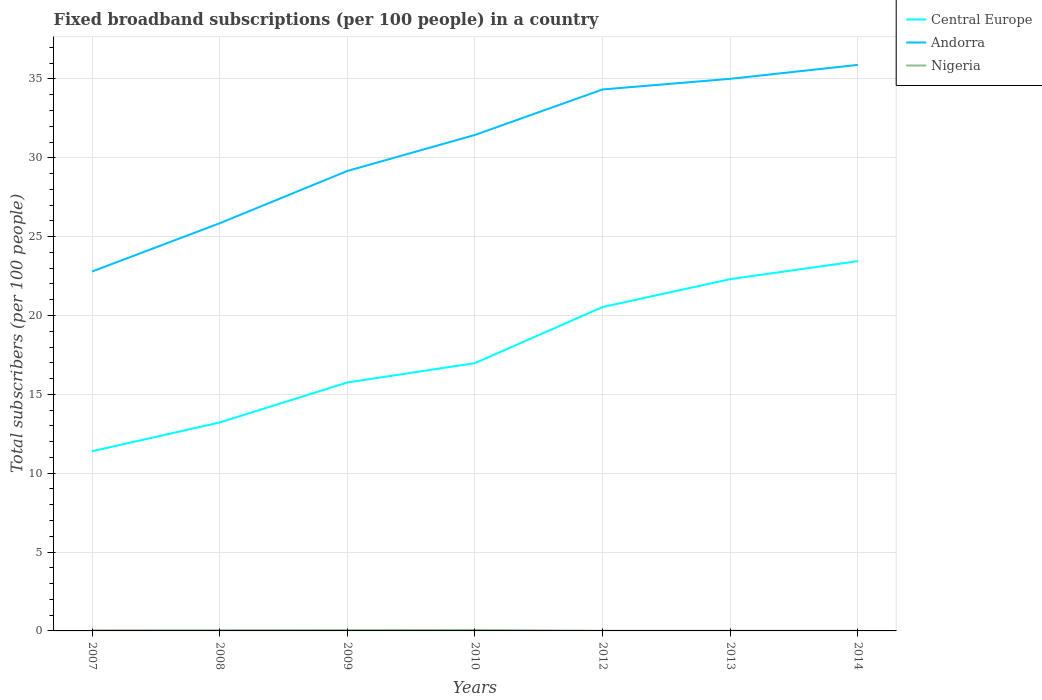How many different coloured lines are there?
Your answer should be compact. 3. Is the number of lines equal to the number of legend labels?
Give a very brief answer. Yes. Across all years, what is the maximum number of broadband subscriptions in Nigeria?
Provide a short and direct response. 0.01. What is the total number of broadband subscriptions in Nigeria in the graph?
Your response must be concise. 0.05. What is the difference between the highest and the second highest number of broadband subscriptions in Andorra?
Provide a short and direct response. 13.1. How many lines are there?
Provide a succinct answer. 3. How many years are there in the graph?
Give a very brief answer. 7. What is the difference between two consecutive major ticks on the Y-axis?
Provide a short and direct response. 5. Are the values on the major ticks of Y-axis written in scientific E-notation?
Offer a very short reply. No. Does the graph contain any zero values?
Offer a very short reply. No. How many legend labels are there?
Your response must be concise. 3. How are the legend labels stacked?
Make the answer very short. Vertical. What is the title of the graph?
Offer a terse response. Fixed broadband subscriptions (per 100 people) in a country. Does "Luxembourg" appear as one of the legend labels in the graph?
Offer a very short reply. No. What is the label or title of the X-axis?
Give a very brief answer. Years. What is the label or title of the Y-axis?
Your response must be concise. Total subscribers (per 100 people). What is the Total subscribers (per 100 people) in Central Europe in 2007?
Your answer should be very brief. 11.39. What is the Total subscribers (per 100 people) in Andorra in 2007?
Offer a very short reply. 22.79. What is the Total subscribers (per 100 people) in Nigeria in 2007?
Offer a very short reply. 0.04. What is the Total subscribers (per 100 people) of Central Europe in 2008?
Offer a terse response. 13.22. What is the Total subscribers (per 100 people) in Andorra in 2008?
Provide a succinct answer. 25.85. What is the Total subscribers (per 100 people) of Nigeria in 2008?
Give a very brief answer. 0.04. What is the Total subscribers (per 100 people) of Central Europe in 2009?
Offer a terse response. 15.75. What is the Total subscribers (per 100 people) in Andorra in 2009?
Make the answer very short. 29.17. What is the Total subscribers (per 100 people) in Nigeria in 2009?
Make the answer very short. 0.05. What is the Total subscribers (per 100 people) of Central Europe in 2010?
Offer a terse response. 16.98. What is the Total subscribers (per 100 people) in Andorra in 2010?
Your answer should be compact. 31.45. What is the Total subscribers (per 100 people) of Nigeria in 2010?
Make the answer very short. 0.06. What is the Total subscribers (per 100 people) of Central Europe in 2012?
Your response must be concise. 20.54. What is the Total subscribers (per 100 people) of Andorra in 2012?
Offer a terse response. 34.34. What is the Total subscribers (per 100 people) of Nigeria in 2012?
Give a very brief answer. 0.01. What is the Total subscribers (per 100 people) in Central Europe in 2013?
Your answer should be very brief. 22.31. What is the Total subscribers (per 100 people) of Andorra in 2013?
Make the answer very short. 35.01. What is the Total subscribers (per 100 people) in Nigeria in 2013?
Your answer should be compact. 0.01. What is the Total subscribers (per 100 people) in Central Europe in 2014?
Give a very brief answer. 23.45. What is the Total subscribers (per 100 people) in Andorra in 2014?
Offer a very short reply. 35.89. What is the Total subscribers (per 100 people) in Nigeria in 2014?
Provide a short and direct response. 0.01. Across all years, what is the maximum Total subscribers (per 100 people) of Central Europe?
Make the answer very short. 23.45. Across all years, what is the maximum Total subscribers (per 100 people) of Andorra?
Ensure brevity in your answer.  35.89. Across all years, what is the maximum Total subscribers (per 100 people) in Nigeria?
Offer a terse response. 0.06. Across all years, what is the minimum Total subscribers (per 100 people) in Central Europe?
Give a very brief answer. 11.39. Across all years, what is the minimum Total subscribers (per 100 people) in Andorra?
Offer a very short reply. 22.79. Across all years, what is the minimum Total subscribers (per 100 people) of Nigeria?
Keep it short and to the point. 0.01. What is the total Total subscribers (per 100 people) in Central Europe in the graph?
Your answer should be compact. 123.64. What is the total Total subscribers (per 100 people) in Andorra in the graph?
Offer a terse response. 214.49. What is the total Total subscribers (per 100 people) in Nigeria in the graph?
Make the answer very short. 0.22. What is the difference between the Total subscribers (per 100 people) of Central Europe in 2007 and that in 2008?
Provide a succinct answer. -1.83. What is the difference between the Total subscribers (per 100 people) in Andorra in 2007 and that in 2008?
Your answer should be compact. -3.06. What is the difference between the Total subscribers (per 100 people) of Nigeria in 2007 and that in 2008?
Offer a terse response. -0.01. What is the difference between the Total subscribers (per 100 people) in Central Europe in 2007 and that in 2009?
Ensure brevity in your answer.  -4.36. What is the difference between the Total subscribers (per 100 people) of Andorra in 2007 and that in 2009?
Your answer should be very brief. -6.38. What is the difference between the Total subscribers (per 100 people) in Nigeria in 2007 and that in 2009?
Your answer should be very brief. -0.02. What is the difference between the Total subscribers (per 100 people) in Central Europe in 2007 and that in 2010?
Your answer should be compact. -5.59. What is the difference between the Total subscribers (per 100 people) of Andorra in 2007 and that in 2010?
Provide a short and direct response. -8.66. What is the difference between the Total subscribers (per 100 people) in Nigeria in 2007 and that in 2010?
Your answer should be very brief. -0.03. What is the difference between the Total subscribers (per 100 people) in Central Europe in 2007 and that in 2012?
Provide a short and direct response. -9.15. What is the difference between the Total subscribers (per 100 people) of Andorra in 2007 and that in 2012?
Your answer should be very brief. -11.55. What is the difference between the Total subscribers (per 100 people) of Nigeria in 2007 and that in 2012?
Provide a succinct answer. 0.03. What is the difference between the Total subscribers (per 100 people) in Central Europe in 2007 and that in 2013?
Make the answer very short. -10.92. What is the difference between the Total subscribers (per 100 people) of Andorra in 2007 and that in 2013?
Offer a terse response. -12.22. What is the difference between the Total subscribers (per 100 people) in Nigeria in 2007 and that in 2013?
Your answer should be compact. 0.03. What is the difference between the Total subscribers (per 100 people) of Central Europe in 2007 and that in 2014?
Provide a succinct answer. -12.06. What is the difference between the Total subscribers (per 100 people) of Andorra in 2007 and that in 2014?
Provide a short and direct response. -13.1. What is the difference between the Total subscribers (per 100 people) in Nigeria in 2007 and that in 2014?
Offer a terse response. 0.03. What is the difference between the Total subscribers (per 100 people) in Central Europe in 2008 and that in 2009?
Make the answer very short. -2.54. What is the difference between the Total subscribers (per 100 people) in Andorra in 2008 and that in 2009?
Provide a short and direct response. -3.32. What is the difference between the Total subscribers (per 100 people) of Nigeria in 2008 and that in 2009?
Offer a terse response. -0.01. What is the difference between the Total subscribers (per 100 people) in Central Europe in 2008 and that in 2010?
Keep it short and to the point. -3.76. What is the difference between the Total subscribers (per 100 people) of Andorra in 2008 and that in 2010?
Provide a short and direct response. -5.6. What is the difference between the Total subscribers (per 100 people) of Nigeria in 2008 and that in 2010?
Offer a very short reply. -0.02. What is the difference between the Total subscribers (per 100 people) in Central Europe in 2008 and that in 2012?
Your answer should be compact. -7.32. What is the difference between the Total subscribers (per 100 people) of Andorra in 2008 and that in 2012?
Your answer should be compact. -8.49. What is the difference between the Total subscribers (per 100 people) of Nigeria in 2008 and that in 2012?
Offer a terse response. 0.04. What is the difference between the Total subscribers (per 100 people) of Central Europe in 2008 and that in 2013?
Your response must be concise. -9.09. What is the difference between the Total subscribers (per 100 people) of Andorra in 2008 and that in 2013?
Provide a short and direct response. -9.16. What is the difference between the Total subscribers (per 100 people) of Nigeria in 2008 and that in 2013?
Give a very brief answer. 0.04. What is the difference between the Total subscribers (per 100 people) of Central Europe in 2008 and that in 2014?
Your response must be concise. -10.23. What is the difference between the Total subscribers (per 100 people) of Andorra in 2008 and that in 2014?
Your answer should be compact. -10.04. What is the difference between the Total subscribers (per 100 people) in Nigeria in 2008 and that in 2014?
Provide a short and direct response. 0.04. What is the difference between the Total subscribers (per 100 people) in Central Europe in 2009 and that in 2010?
Provide a short and direct response. -1.23. What is the difference between the Total subscribers (per 100 people) of Andorra in 2009 and that in 2010?
Make the answer very short. -2.29. What is the difference between the Total subscribers (per 100 people) of Nigeria in 2009 and that in 2010?
Offer a terse response. -0.01. What is the difference between the Total subscribers (per 100 people) in Central Europe in 2009 and that in 2012?
Offer a terse response. -4.79. What is the difference between the Total subscribers (per 100 people) in Andorra in 2009 and that in 2012?
Your answer should be compact. -5.17. What is the difference between the Total subscribers (per 100 people) in Nigeria in 2009 and that in 2012?
Your answer should be compact. 0.04. What is the difference between the Total subscribers (per 100 people) of Central Europe in 2009 and that in 2013?
Give a very brief answer. -6.55. What is the difference between the Total subscribers (per 100 people) of Andorra in 2009 and that in 2013?
Make the answer very short. -5.84. What is the difference between the Total subscribers (per 100 people) in Nigeria in 2009 and that in 2013?
Ensure brevity in your answer.  0.04. What is the difference between the Total subscribers (per 100 people) of Central Europe in 2009 and that in 2014?
Your answer should be compact. -7.69. What is the difference between the Total subscribers (per 100 people) of Andorra in 2009 and that in 2014?
Make the answer very short. -6.73. What is the difference between the Total subscribers (per 100 people) of Nigeria in 2009 and that in 2014?
Your answer should be compact. 0.04. What is the difference between the Total subscribers (per 100 people) of Central Europe in 2010 and that in 2012?
Provide a succinct answer. -3.56. What is the difference between the Total subscribers (per 100 people) in Andorra in 2010 and that in 2012?
Offer a very short reply. -2.88. What is the difference between the Total subscribers (per 100 people) of Nigeria in 2010 and that in 2012?
Ensure brevity in your answer.  0.05. What is the difference between the Total subscribers (per 100 people) of Central Europe in 2010 and that in 2013?
Give a very brief answer. -5.33. What is the difference between the Total subscribers (per 100 people) of Andorra in 2010 and that in 2013?
Provide a short and direct response. -3.56. What is the difference between the Total subscribers (per 100 people) in Nigeria in 2010 and that in 2013?
Keep it short and to the point. 0.05. What is the difference between the Total subscribers (per 100 people) in Central Europe in 2010 and that in 2014?
Give a very brief answer. -6.47. What is the difference between the Total subscribers (per 100 people) in Andorra in 2010 and that in 2014?
Offer a terse response. -4.44. What is the difference between the Total subscribers (per 100 people) in Nigeria in 2010 and that in 2014?
Keep it short and to the point. 0.05. What is the difference between the Total subscribers (per 100 people) in Central Europe in 2012 and that in 2013?
Your answer should be very brief. -1.77. What is the difference between the Total subscribers (per 100 people) in Andorra in 2012 and that in 2013?
Your answer should be very brief. -0.67. What is the difference between the Total subscribers (per 100 people) in Nigeria in 2012 and that in 2013?
Ensure brevity in your answer.  -0. What is the difference between the Total subscribers (per 100 people) of Central Europe in 2012 and that in 2014?
Provide a succinct answer. -2.91. What is the difference between the Total subscribers (per 100 people) in Andorra in 2012 and that in 2014?
Provide a succinct answer. -1.56. What is the difference between the Total subscribers (per 100 people) in Nigeria in 2012 and that in 2014?
Your response must be concise. -0. What is the difference between the Total subscribers (per 100 people) of Central Europe in 2013 and that in 2014?
Give a very brief answer. -1.14. What is the difference between the Total subscribers (per 100 people) of Andorra in 2013 and that in 2014?
Give a very brief answer. -0.88. What is the difference between the Total subscribers (per 100 people) in Nigeria in 2013 and that in 2014?
Give a very brief answer. -0. What is the difference between the Total subscribers (per 100 people) of Central Europe in 2007 and the Total subscribers (per 100 people) of Andorra in 2008?
Keep it short and to the point. -14.46. What is the difference between the Total subscribers (per 100 people) of Central Europe in 2007 and the Total subscribers (per 100 people) of Nigeria in 2008?
Offer a very short reply. 11.35. What is the difference between the Total subscribers (per 100 people) of Andorra in 2007 and the Total subscribers (per 100 people) of Nigeria in 2008?
Give a very brief answer. 22.74. What is the difference between the Total subscribers (per 100 people) in Central Europe in 2007 and the Total subscribers (per 100 people) in Andorra in 2009?
Your answer should be compact. -17.77. What is the difference between the Total subscribers (per 100 people) in Central Europe in 2007 and the Total subscribers (per 100 people) in Nigeria in 2009?
Keep it short and to the point. 11.34. What is the difference between the Total subscribers (per 100 people) in Andorra in 2007 and the Total subscribers (per 100 people) in Nigeria in 2009?
Offer a very short reply. 22.74. What is the difference between the Total subscribers (per 100 people) in Central Europe in 2007 and the Total subscribers (per 100 people) in Andorra in 2010?
Offer a terse response. -20.06. What is the difference between the Total subscribers (per 100 people) of Central Europe in 2007 and the Total subscribers (per 100 people) of Nigeria in 2010?
Your answer should be very brief. 11.33. What is the difference between the Total subscribers (per 100 people) in Andorra in 2007 and the Total subscribers (per 100 people) in Nigeria in 2010?
Your answer should be very brief. 22.73. What is the difference between the Total subscribers (per 100 people) of Central Europe in 2007 and the Total subscribers (per 100 people) of Andorra in 2012?
Your response must be concise. -22.94. What is the difference between the Total subscribers (per 100 people) of Central Europe in 2007 and the Total subscribers (per 100 people) of Nigeria in 2012?
Your answer should be very brief. 11.38. What is the difference between the Total subscribers (per 100 people) in Andorra in 2007 and the Total subscribers (per 100 people) in Nigeria in 2012?
Offer a very short reply. 22.78. What is the difference between the Total subscribers (per 100 people) in Central Europe in 2007 and the Total subscribers (per 100 people) in Andorra in 2013?
Provide a succinct answer. -23.62. What is the difference between the Total subscribers (per 100 people) in Central Europe in 2007 and the Total subscribers (per 100 people) in Nigeria in 2013?
Offer a very short reply. 11.38. What is the difference between the Total subscribers (per 100 people) in Andorra in 2007 and the Total subscribers (per 100 people) in Nigeria in 2013?
Your response must be concise. 22.78. What is the difference between the Total subscribers (per 100 people) in Central Europe in 2007 and the Total subscribers (per 100 people) in Andorra in 2014?
Your response must be concise. -24.5. What is the difference between the Total subscribers (per 100 people) in Central Europe in 2007 and the Total subscribers (per 100 people) in Nigeria in 2014?
Provide a short and direct response. 11.38. What is the difference between the Total subscribers (per 100 people) in Andorra in 2007 and the Total subscribers (per 100 people) in Nigeria in 2014?
Offer a terse response. 22.78. What is the difference between the Total subscribers (per 100 people) of Central Europe in 2008 and the Total subscribers (per 100 people) of Andorra in 2009?
Provide a short and direct response. -15.95. What is the difference between the Total subscribers (per 100 people) in Central Europe in 2008 and the Total subscribers (per 100 people) in Nigeria in 2009?
Offer a very short reply. 13.17. What is the difference between the Total subscribers (per 100 people) of Andorra in 2008 and the Total subscribers (per 100 people) of Nigeria in 2009?
Keep it short and to the point. 25.8. What is the difference between the Total subscribers (per 100 people) in Central Europe in 2008 and the Total subscribers (per 100 people) in Andorra in 2010?
Your answer should be very brief. -18.23. What is the difference between the Total subscribers (per 100 people) of Central Europe in 2008 and the Total subscribers (per 100 people) of Nigeria in 2010?
Make the answer very short. 13.16. What is the difference between the Total subscribers (per 100 people) in Andorra in 2008 and the Total subscribers (per 100 people) in Nigeria in 2010?
Your answer should be very brief. 25.79. What is the difference between the Total subscribers (per 100 people) of Central Europe in 2008 and the Total subscribers (per 100 people) of Andorra in 2012?
Provide a short and direct response. -21.12. What is the difference between the Total subscribers (per 100 people) in Central Europe in 2008 and the Total subscribers (per 100 people) in Nigeria in 2012?
Make the answer very short. 13.21. What is the difference between the Total subscribers (per 100 people) of Andorra in 2008 and the Total subscribers (per 100 people) of Nigeria in 2012?
Offer a terse response. 25.84. What is the difference between the Total subscribers (per 100 people) in Central Europe in 2008 and the Total subscribers (per 100 people) in Andorra in 2013?
Keep it short and to the point. -21.79. What is the difference between the Total subscribers (per 100 people) of Central Europe in 2008 and the Total subscribers (per 100 people) of Nigeria in 2013?
Your response must be concise. 13.21. What is the difference between the Total subscribers (per 100 people) of Andorra in 2008 and the Total subscribers (per 100 people) of Nigeria in 2013?
Offer a very short reply. 25.84. What is the difference between the Total subscribers (per 100 people) of Central Europe in 2008 and the Total subscribers (per 100 people) of Andorra in 2014?
Provide a short and direct response. -22.68. What is the difference between the Total subscribers (per 100 people) in Central Europe in 2008 and the Total subscribers (per 100 people) in Nigeria in 2014?
Give a very brief answer. 13.21. What is the difference between the Total subscribers (per 100 people) of Andorra in 2008 and the Total subscribers (per 100 people) of Nigeria in 2014?
Your answer should be very brief. 25.84. What is the difference between the Total subscribers (per 100 people) in Central Europe in 2009 and the Total subscribers (per 100 people) in Andorra in 2010?
Your answer should be compact. -15.7. What is the difference between the Total subscribers (per 100 people) in Central Europe in 2009 and the Total subscribers (per 100 people) in Nigeria in 2010?
Ensure brevity in your answer.  15.69. What is the difference between the Total subscribers (per 100 people) of Andorra in 2009 and the Total subscribers (per 100 people) of Nigeria in 2010?
Make the answer very short. 29.1. What is the difference between the Total subscribers (per 100 people) in Central Europe in 2009 and the Total subscribers (per 100 people) in Andorra in 2012?
Your answer should be compact. -18.58. What is the difference between the Total subscribers (per 100 people) in Central Europe in 2009 and the Total subscribers (per 100 people) in Nigeria in 2012?
Ensure brevity in your answer.  15.75. What is the difference between the Total subscribers (per 100 people) of Andorra in 2009 and the Total subscribers (per 100 people) of Nigeria in 2012?
Give a very brief answer. 29.16. What is the difference between the Total subscribers (per 100 people) of Central Europe in 2009 and the Total subscribers (per 100 people) of Andorra in 2013?
Your answer should be very brief. -19.26. What is the difference between the Total subscribers (per 100 people) of Central Europe in 2009 and the Total subscribers (per 100 people) of Nigeria in 2013?
Offer a very short reply. 15.74. What is the difference between the Total subscribers (per 100 people) in Andorra in 2009 and the Total subscribers (per 100 people) in Nigeria in 2013?
Offer a very short reply. 29.16. What is the difference between the Total subscribers (per 100 people) in Central Europe in 2009 and the Total subscribers (per 100 people) in Andorra in 2014?
Provide a succinct answer. -20.14. What is the difference between the Total subscribers (per 100 people) in Central Europe in 2009 and the Total subscribers (per 100 people) in Nigeria in 2014?
Offer a very short reply. 15.74. What is the difference between the Total subscribers (per 100 people) in Andorra in 2009 and the Total subscribers (per 100 people) in Nigeria in 2014?
Your answer should be compact. 29.16. What is the difference between the Total subscribers (per 100 people) in Central Europe in 2010 and the Total subscribers (per 100 people) in Andorra in 2012?
Offer a terse response. -17.35. What is the difference between the Total subscribers (per 100 people) of Central Europe in 2010 and the Total subscribers (per 100 people) of Nigeria in 2012?
Ensure brevity in your answer.  16.97. What is the difference between the Total subscribers (per 100 people) in Andorra in 2010 and the Total subscribers (per 100 people) in Nigeria in 2012?
Offer a very short reply. 31.44. What is the difference between the Total subscribers (per 100 people) in Central Europe in 2010 and the Total subscribers (per 100 people) in Andorra in 2013?
Provide a short and direct response. -18.03. What is the difference between the Total subscribers (per 100 people) of Central Europe in 2010 and the Total subscribers (per 100 people) of Nigeria in 2013?
Make the answer very short. 16.97. What is the difference between the Total subscribers (per 100 people) of Andorra in 2010 and the Total subscribers (per 100 people) of Nigeria in 2013?
Offer a terse response. 31.44. What is the difference between the Total subscribers (per 100 people) of Central Europe in 2010 and the Total subscribers (per 100 people) of Andorra in 2014?
Offer a terse response. -18.91. What is the difference between the Total subscribers (per 100 people) in Central Europe in 2010 and the Total subscribers (per 100 people) in Nigeria in 2014?
Provide a succinct answer. 16.97. What is the difference between the Total subscribers (per 100 people) of Andorra in 2010 and the Total subscribers (per 100 people) of Nigeria in 2014?
Give a very brief answer. 31.44. What is the difference between the Total subscribers (per 100 people) in Central Europe in 2012 and the Total subscribers (per 100 people) in Andorra in 2013?
Your answer should be very brief. -14.47. What is the difference between the Total subscribers (per 100 people) in Central Europe in 2012 and the Total subscribers (per 100 people) in Nigeria in 2013?
Give a very brief answer. 20.53. What is the difference between the Total subscribers (per 100 people) in Andorra in 2012 and the Total subscribers (per 100 people) in Nigeria in 2013?
Your answer should be compact. 34.33. What is the difference between the Total subscribers (per 100 people) in Central Europe in 2012 and the Total subscribers (per 100 people) in Andorra in 2014?
Make the answer very short. -15.35. What is the difference between the Total subscribers (per 100 people) of Central Europe in 2012 and the Total subscribers (per 100 people) of Nigeria in 2014?
Keep it short and to the point. 20.53. What is the difference between the Total subscribers (per 100 people) of Andorra in 2012 and the Total subscribers (per 100 people) of Nigeria in 2014?
Offer a very short reply. 34.33. What is the difference between the Total subscribers (per 100 people) in Central Europe in 2013 and the Total subscribers (per 100 people) in Andorra in 2014?
Make the answer very short. -13.59. What is the difference between the Total subscribers (per 100 people) of Central Europe in 2013 and the Total subscribers (per 100 people) of Nigeria in 2014?
Your answer should be compact. 22.3. What is the difference between the Total subscribers (per 100 people) in Andorra in 2013 and the Total subscribers (per 100 people) in Nigeria in 2014?
Offer a terse response. 35. What is the average Total subscribers (per 100 people) of Central Europe per year?
Offer a very short reply. 17.66. What is the average Total subscribers (per 100 people) in Andorra per year?
Offer a terse response. 30.64. What is the average Total subscribers (per 100 people) of Nigeria per year?
Offer a terse response. 0.03. In the year 2007, what is the difference between the Total subscribers (per 100 people) in Central Europe and Total subscribers (per 100 people) in Andorra?
Your answer should be compact. -11.4. In the year 2007, what is the difference between the Total subscribers (per 100 people) in Central Europe and Total subscribers (per 100 people) in Nigeria?
Ensure brevity in your answer.  11.36. In the year 2007, what is the difference between the Total subscribers (per 100 people) of Andorra and Total subscribers (per 100 people) of Nigeria?
Keep it short and to the point. 22.75. In the year 2008, what is the difference between the Total subscribers (per 100 people) of Central Europe and Total subscribers (per 100 people) of Andorra?
Provide a short and direct response. -12.63. In the year 2008, what is the difference between the Total subscribers (per 100 people) in Central Europe and Total subscribers (per 100 people) in Nigeria?
Keep it short and to the point. 13.17. In the year 2008, what is the difference between the Total subscribers (per 100 people) in Andorra and Total subscribers (per 100 people) in Nigeria?
Offer a very short reply. 25.81. In the year 2009, what is the difference between the Total subscribers (per 100 people) in Central Europe and Total subscribers (per 100 people) in Andorra?
Your response must be concise. -13.41. In the year 2009, what is the difference between the Total subscribers (per 100 people) of Central Europe and Total subscribers (per 100 people) of Nigeria?
Offer a very short reply. 15.7. In the year 2009, what is the difference between the Total subscribers (per 100 people) of Andorra and Total subscribers (per 100 people) of Nigeria?
Keep it short and to the point. 29.11. In the year 2010, what is the difference between the Total subscribers (per 100 people) in Central Europe and Total subscribers (per 100 people) in Andorra?
Keep it short and to the point. -14.47. In the year 2010, what is the difference between the Total subscribers (per 100 people) in Central Europe and Total subscribers (per 100 people) in Nigeria?
Keep it short and to the point. 16.92. In the year 2010, what is the difference between the Total subscribers (per 100 people) of Andorra and Total subscribers (per 100 people) of Nigeria?
Give a very brief answer. 31.39. In the year 2012, what is the difference between the Total subscribers (per 100 people) of Central Europe and Total subscribers (per 100 people) of Andorra?
Make the answer very short. -13.8. In the year 2012, what is the difference between the Total subscribers (per 100 people) in Central Europe and Total subscribers (per 100 people) in Nigeria?
Your answer should be very brief. 20.53. In the year 2012, what is the difference between the Total subscribers (per 100 people) in Andorra and Total subscribers (per 100 people) in Nigeria?
Make the answer very short. 34.33. In the year 2013, what is the difference between the Total subscribers (per 100 people) in Central Europe and Total subscribers (per 100 people) in Andorra?
Provide a succinct answer. -12.7. In the year 2013, what is the difference between the Total subscribers (per 100 people) of Central Europe and Total subscribers (per 100 people) of Nigeria?
Your response must be concise. 22.3. In the year 2013, what is the difference between the Total subscribers (per 100 people) in Andorra and Total subscribers (per 100 people) in Nigeria?
Offer a very short reply. 35. In the year 2014, what is the difference between the Total subscribers (per 100 people) of Central Europe and Total subscribers (per 100 people) of Andorra?
Provide a short and direct response. -12.45. In the year 2014, what is the difference between the Total subscribers (per 100 people) in Central Europe and Total subscribers (per 100 people) in Nigeria?
Keep it short and to the point. 23.44. In the year 2014, what is the difference between the Total subscribers (per 100 people) of Andorra and Total subscribers (per 100 people) of Nigeria?
Ensure brevity in your answer.  35.88. What is the ratio of the Total subscribers (per 100 people) of Central Europe in 2007 to that in 2008?
Your answer should be compact. 0.86. What is the ratio of the Total subscribers (per 100 people) of Andorra in 2007 to that in 2008?
Provide a succinct answer. 0.88. What is the ratio of the Total subscribers (per 100 people) in Nigeria in 2007 to that in 2008?
Your answer should be compact. 0.81. What is the ratio of the Total subscribers (per 100 people) of Central Europe in 2007 to that in 2009?
Your answer should be compact. 0.72. What is the ratio of the Total subscribers (per 100 people) of Andorra in 2007 to that in 2009?
Ensure brevity in your answer.  0.78. What is the ratio of the Total subscribers (per 100 people) in Nigeria in 2007 to that in 2009?
Keep it short and to the point. 0.69. What is the ratio of the Total subscribers (per 100 people) of Central Europe in 2007 to that in 2010?
Give a very brief answer. 0.67. What is the ratio of the Total subscribers (per 100 people) in Andorra in 2007 to that in 2010?
Offer a terse response. 0.72. What is the ratio of the Total subscribers (per 100 people) in Nigeria in 2007 to that in 2010?
Your answer should be compact. 0.59. What is the ratio of the Total subscribers (per 100 people) in Central Europe in 2007 to that in 2012?
Offer a very short reply. 0.55. What is the ratio of the Total subscribers (per 100 people) of Andorra in 2007 to that in 2012?
Ensure brevity in your answer.  0.66. What is the ratio of the Total subscribers (per 100 people) of Nigeria in 2007 to that in 2012?
Keep it short and to the point. 4.31. What is the ratio of the Total subscribers (per 100 people) in Central Europe in 2007 to that in 2013?
Ensure brevity in your answer.  0.51. What is the ratio of the Total subscribers (per 100 people) of Andorra in 2007 to that in 2013?
Give a very brief answer. 0.65. What is the ratio of the Total subscribers (per 100 people) of Nigeria in 2007 to that in 2013?
Offer a terse response. 4.2. What is the ratio of the Total subscribers (per 100 people) in Central Europe in 2007 to that in 2014?
Provide a succinct answer. 0.49. What is the ratio of the Total subscribers (per 100 people) in Andorra in 2007 to that in 2014?
Your answer should be very brief. 0.63. What is the ratio of the Total subscribers (per 100 people) of Nigeria in 2007 to that in 2014?
Keep it short and to the point. 4.13. What is the ratio of the Total subscribers (per 100 people) of Central Europe in 2008 to that in 2009?
Ensure brevity in your answer.  0.84. What is the ratio of the Total subscribers (per 100 people) of Andorra in 2008 to that in 2009?
Keep it short and to the point. 0.89. What is the ratio of the Total subscribers (per 100 people) in Nigeria in 2008 to that in 2009?
Your answer should be very brief. 0.85. What is the ratio of the Total subscribers (per 100 people) in Central Europe in 2008 to that in 2010?
Provide a succinct answer. 0.78. What is the ratio of the Total subscribers (per 100 people) of Andorra in 2008 to that in 2010?
Provide a succinct answer. 0.82. What is the ratio of the Total subscribers (per 100 people) in Nigeria in 2008 to that in 2010?
Your response must be concise. 0.72. What is the ratio of the Total subscribers (per 100 people) of Central Europe in 2008 to that in 2012?
Give a very brief answer. 0.64. What is the ratio of the Total subscribers (per 100 people) of Andorra in 2008 to that in 2012?
Provide a short and direct response. 0.75. What is the ratio of the Total subscribers (per 100 people) of Nigeria in 2008 to that in 2012?
Offer a very short reply. 5.3. What is the ratio of the Total subscribers (per 100 people) in Central Europe in 2008 to that in 2013?
Your answer should be compact. 0.59. What is the ratio of the Total subscribers (per 100 people) of Andorra in 2008 to that in 2013?
Provide a short and direct response. 0.74. What is the ratio of the Total subscribers (per 100 people) of Nigeria in 2008 to that in 2013?
Your answer should be very brief. 5.17. What is the ratio of the Total subscribers (per 100 people) of Central Europe in 2008 to that in 2014?
Make the answer very short. 0.56. What is the ratio of the Total subscribers (per 100 people) of Andorra in 2008 to that in 2014?
Give a very brief answer. 0.72. What is the ratio of the Total subscribers (per 100 people) in Nigeria in 2008 to that in 2014?
Make the answer very short. 5.08. What is the ratio of the Total subscribers (per 100 people) in Central Europe in 2009 to that in 2010?
Provide a short and direct response. 0.93. What is the ratio of the Total subscribers (per 100 people) in Andorra in 2009 to that in 2010?
Give a very brief answer. 0.93. What is the ratio of the Total subscribers (per 100 people) in Central Europe in 2009 to that in 2012?
Your answer should be very brief. 0.77. What is the ratio of the Total subscribers (per 100 people) in Andorra in 2009 to that in 2012?
Offer a very short reply. 0.85. What is the ratio of the Total subscribers (per 100 people) in Nigeria in 2009 to that in 2012?
Your answer should be very brief. 6.24. What is the ratio of the Total subscribers (per 100 people) in Central Europe in 2009 to that in 2013?
Provide a succinct answer. 0.71. What is the ratio of the Total subscribers (per 100 people) of Andorra in 2009 to that in 2013?
Your response must be concise. 0.83. What is the ratio of the Total subscribers (per 100 people) in Nigeria in 2009 to that in 2013?
Your answer should be very brief. 6.09. What is the ratio of the Total subscribers (per 100 people) of Central Europe in 2009 to that in 2014?
Your answer should be very brief. 0.67. What is the ratio of the Total subscribers (per 100 people) in Andorra in 2009 to that in 2014?
Provide a succinct answer. 0.81. What is the ratio of the Total subscribers (per 100 people) in Nigeria in 2009 to that in 2014?
Keep it short and to the point. 5.98. What is the ratio of the Total subscribers (per 100 people) of Central Europe in 2010 to that in 2012?
Keep it short and to the point. 0.83. What is the ratio of the Total subscribers (per 100 people) of Andorra in 2010 to that in 2012?
Make the answer very short. 0.92. What is the ratio of the Total subscribers (per 100 people) in Nigeria in 2010 to that in 2012?
Provide a succinct answer. 7.34. What is the ratio of the Total subscribers (per 100 people) in Central Europe in 2010 to that in 2013?
Offer a terse response. 0.76. What is the ratio of the Total subscribers (per 100 people) in Andorra in 2010 to that in 2013?
Ensure brevity in your answer.  0.9. What is the ratio of the Total subscribers (per 100 people) of Nigeria in 2010 to that in 2013?
Make the answer very short. 7.16. What is the ratio of the Total subscribers (per 100 people) in Central Europe in 2010 to that in 2014?
Your response must be concise. 0.72. What is the ratio of the Total subscribers (per 100 people) in Andorra in 2010 to that in 2014?
Keep it short and to the point. 0.88. What is the ratio of the Total subscribers (per 100 people) in Nigeria in 2010 to that in 2014?
Provide a succinct answer. 7.04. What is the ratio of the Total subscribers (per 100 people) in Central Europe in 2012 to that in 2013?
Provide a succinct answer. 0.92. What is the ratio of the Total subscribers (per 100 people) of Andorra in 2012 to that in 2013?
Give a very brief answer. 0.98. What is the ratio of the Total subscribers (per 100 people) of Central Europe in 2012 to that in 2014?
Provide a succinct answer. 0.88. What is the ratio of the Total subscribers (per 100 people) in Andorra in 2012 to that in 2014?
Provide a short and direct response. 0.96. What is the ratio of the Total subscribers (per 100 people) of Nigeria in 2012 to that in 2014?
Give a very brief answer. 0.96. What is the ratio of the Total subscribers (per 100 people) in Central Europe in 2013 to that in 2014?
Offer a very short reply. 0.95. What is the ratio of the Total subscribers (per 100 people) of Andorra in 2013 to that in 2014?
Your answer should be compact. 0.98. What is the ratio of the Total subscribers (per 100 people) of Nigeria in 2013 to that in 2014?
Provide a short and direct response. 0.98. What is the difference between the highest and the second highest Total subscribers (per 100 people) of Central Europe?
Make the answer very short. 1.14. What is the difference between the highest and the second highest Total subscribers (per 100 people) in Andorra?
Your response must be concise. 0.88. What is the difference between the highest and the second highest Total subscribers (per 100 people) in Nigeria?
Your answer should be very brief. 0.01. What is the difference between the highest and the lowest Total subscribers (per 100 people) of Central Europe?
Offer a very short reply. 12.06. What is the difference between the highest and the lowest Total subscribers (per 100 people) in Andorra?
Provide a succinct answer. 13.1. What is the difference between the highest and the lowest Total subscribers (per 100 people) of Nigeria?
Your answer should be very brief. 0.05. 